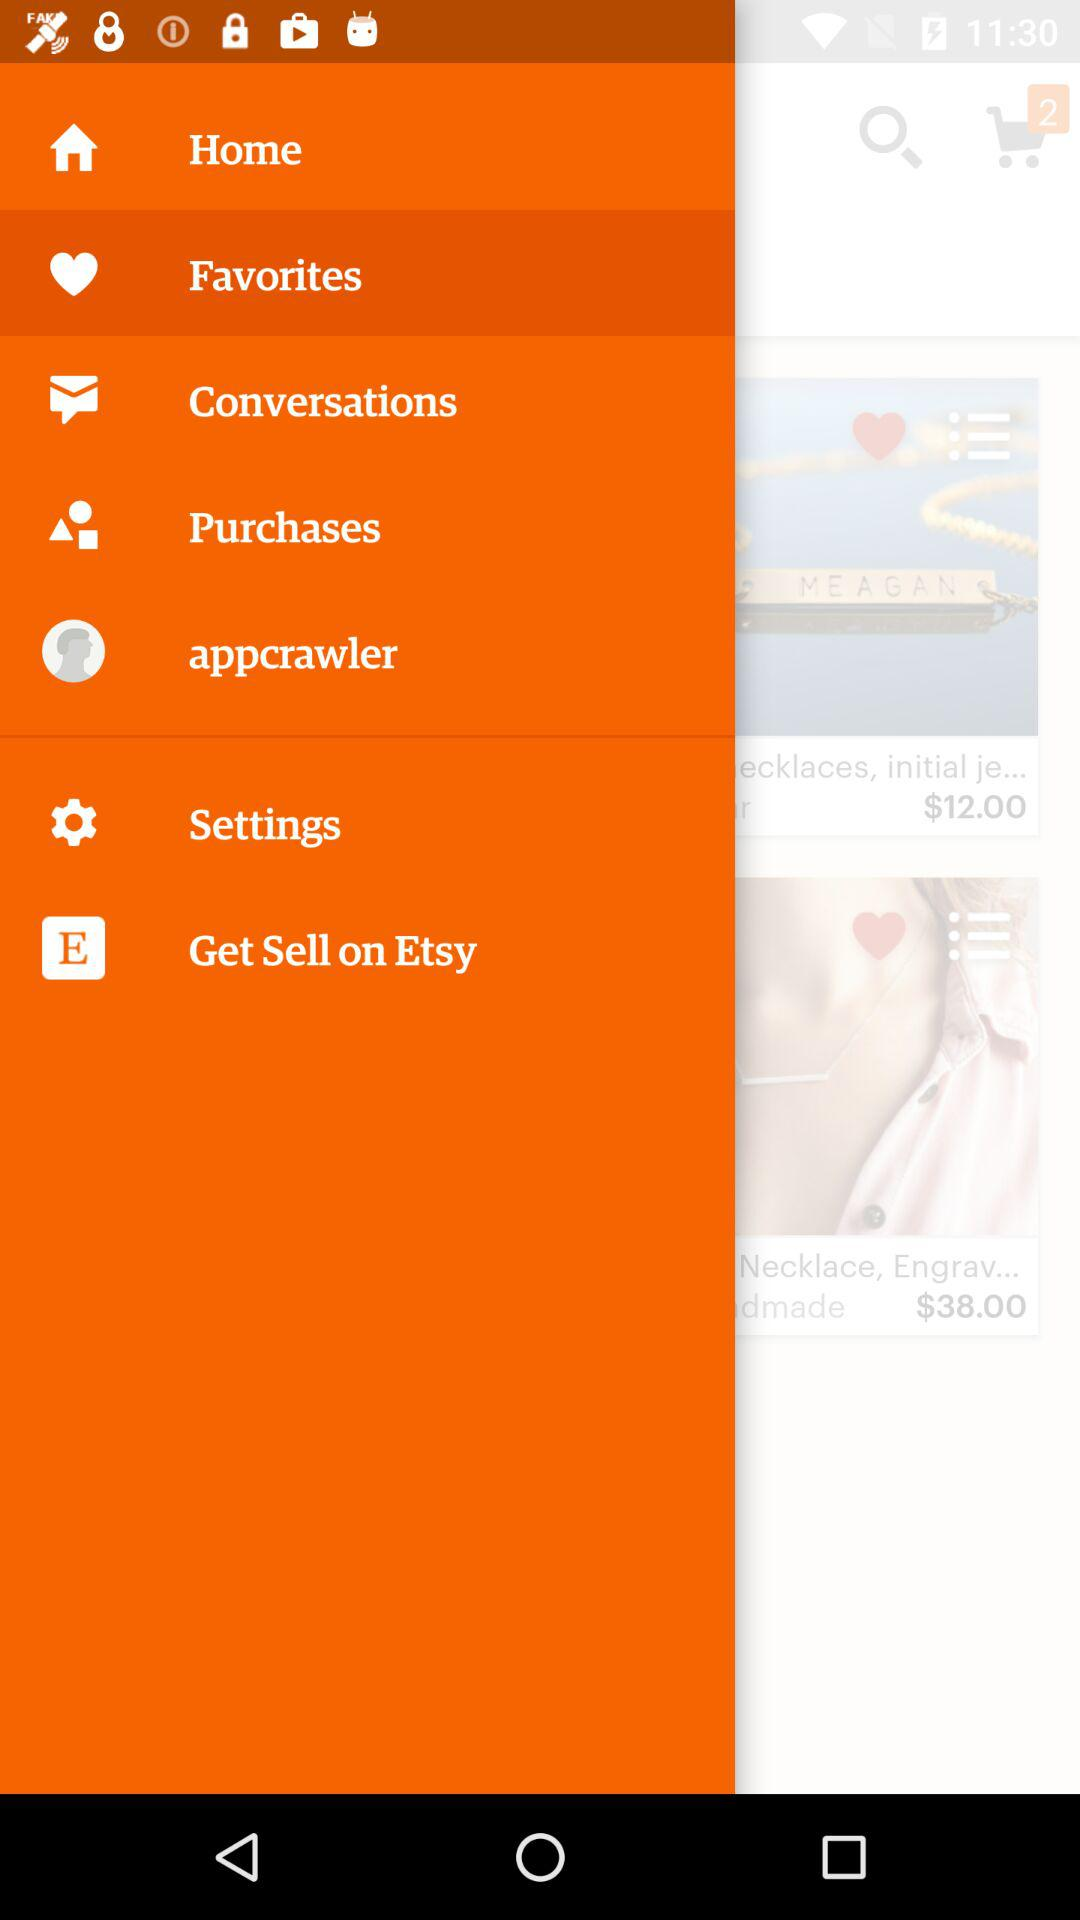How many items are in the cart?
Answer the question using a single word or phrase. 2 